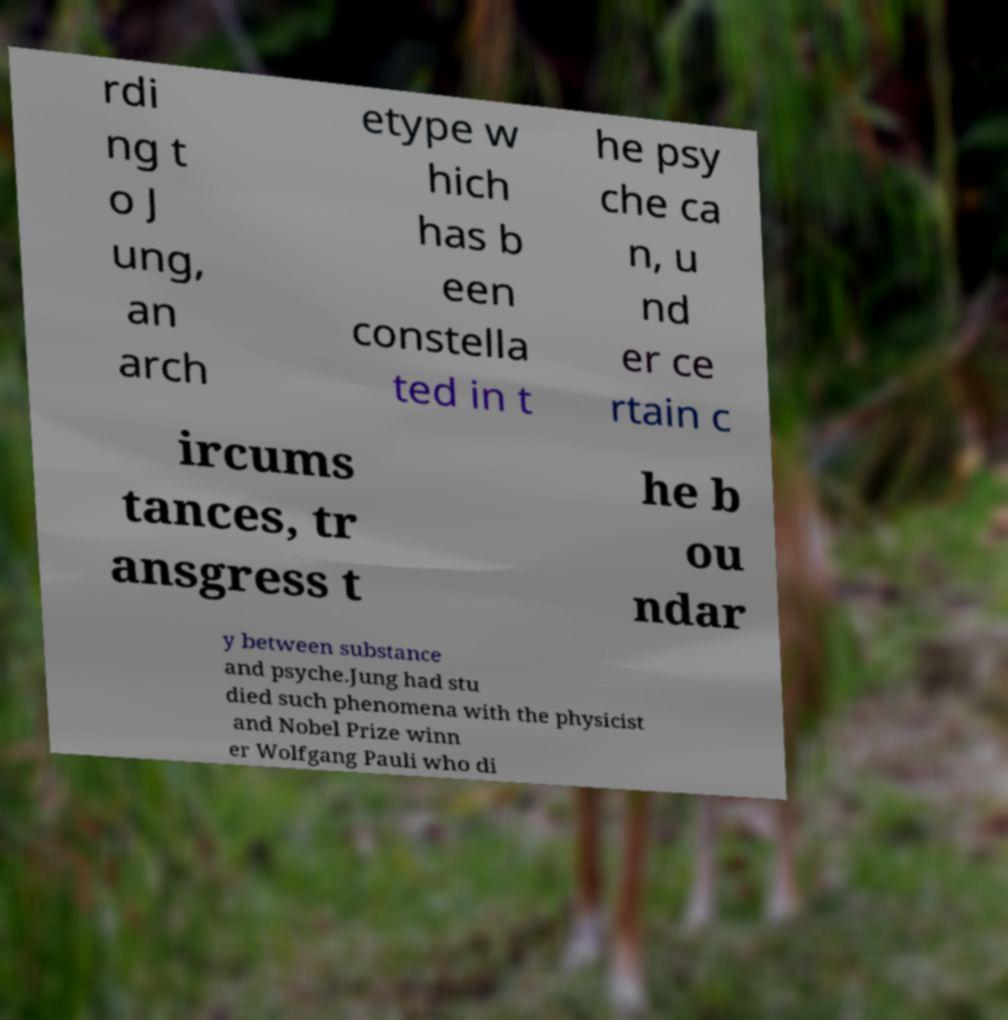Can you read and provide the text displayed in the image?This photo seems to have some interesting text. Can you extract and type it out for me? rdi ng t o J ung, an arch etype w hich has b een constella ted in t he psy che ca n, u nd er ce rtain c ircums tances, tr ansgress t he b ou ndar y between substance and psyche.Jung had stu died such phenomena with the physicist and Nobel Prize winn er Wolfgang Pauli who di 